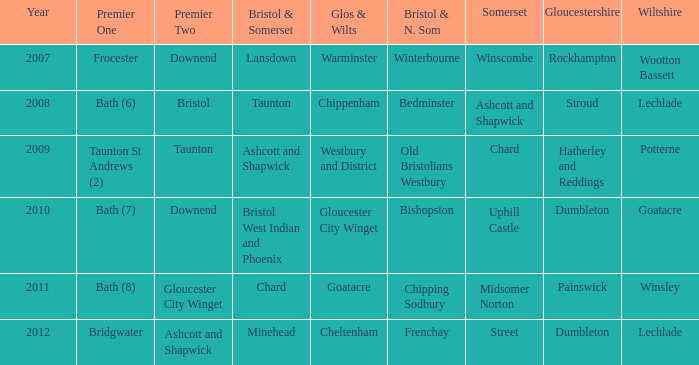In what year did glos & wilts become known as gloucester city winget? 2010.0. Parse the full table. {'header': ['Year', 'Premier One', 'Premier Two', 'Bristol & Somerset', 'Glos & Wilts', 'Bristol & N. Som', 'Somerset', 'Gloucestershire', 'Wiltshire'], 'rows': [['2007', 'Frocester', 'Downend', 'Lansdown', 'Warminster', 'Winterbourne', 'Winscombe', 'Rockhampton', 'Wootton Bassett'], ['2008', 'Bath (6)', 'Bristol', 'Taunton', 'Chippenham', 'Bedminster', 'Ashcott and Shapwick', 'Stroud', 'Lechlade'], ['2009', 'Taunton St Andrews (2)', 'Taunton', 'Ashcott and Shapwick', 'Westbury and District', 'Old Bristolians Westbury', 'Chard', 'Hatherley and Reddings', 'Potterne'], ['2010', 'Bath (7)', 'Downend', 'Bristol West Indian and Phoenix', 'Gloucester City Winget', 'Bishopston', 'Uphill Castle', 'Dumbleton', 'Goatacre'], ['2011', 'Bath (8)', 'Gloucester City Winget', 'Chard', 'Goatacre', 'Chipping Sodbury', 'Midsomer Norton', 'Painswick', 'Winsley'], ['2012', 'Bridgwater', 'Ashcott and Shapwick', 'Minehead', 'Cheltenham', 'Frenchay', 'Street', 'Dumbleton', 'Lechlade']]} 